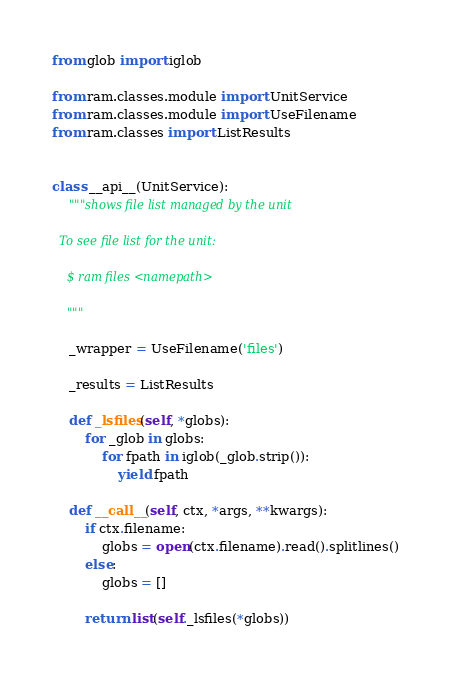<code> <loc_0><loc_0><loc_500><loc_500><_Python_>from glob import iglob

from ram.classes.module import UnitService
from ram.classes.module import UseFilename
from ram.classes import ListResults


class __api__(UnitService):
    """shows file list managed by the unit

  To see file list for the unit:

    $ ram files <namepath>

    """

    _wrapper = UseFilename('files')

    _results = ListResults

    def _lsfiles(self, *globs):
        for _glob in globs:
            for fpath in iglob(_glob.strip()):
                yield fpath

    def __call__(self, ctx, *args, **kwargs):
        if ctx.filename:
            globs = open(ctx.filename).read().splitlines()
        else:
            globs = []

        return list(self._lsfiles(*globs))
</code> 